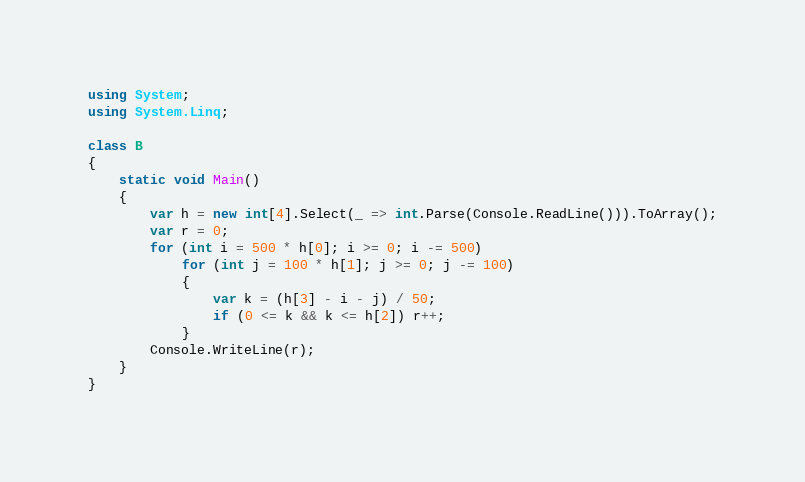<code> <loc_0><loc_0><loc_500><loc_500><_C#_>using System;
using System.Linq;

class B
{
	static void Main()
	{
		var h = new int[4].Select(_ => int.Parse(Console.ReadLine())).ToArray();
		var r = 0;
		for (int i = 500 * h[0]; i >= 0; i -= 500)
			for (int j = 100 * h[1]; j >= 0; j -= 100)
			{
				var k = (h[3] - i - j) / 50;
				if (0 <= k && k <= h[2]) r++;
			}
		Console.WriteLine(r);
	}
}
</code> 